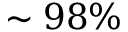<formula> <loc_0><loc_0><loc_500><loc_500>\sim 9 8 \%</formula> 